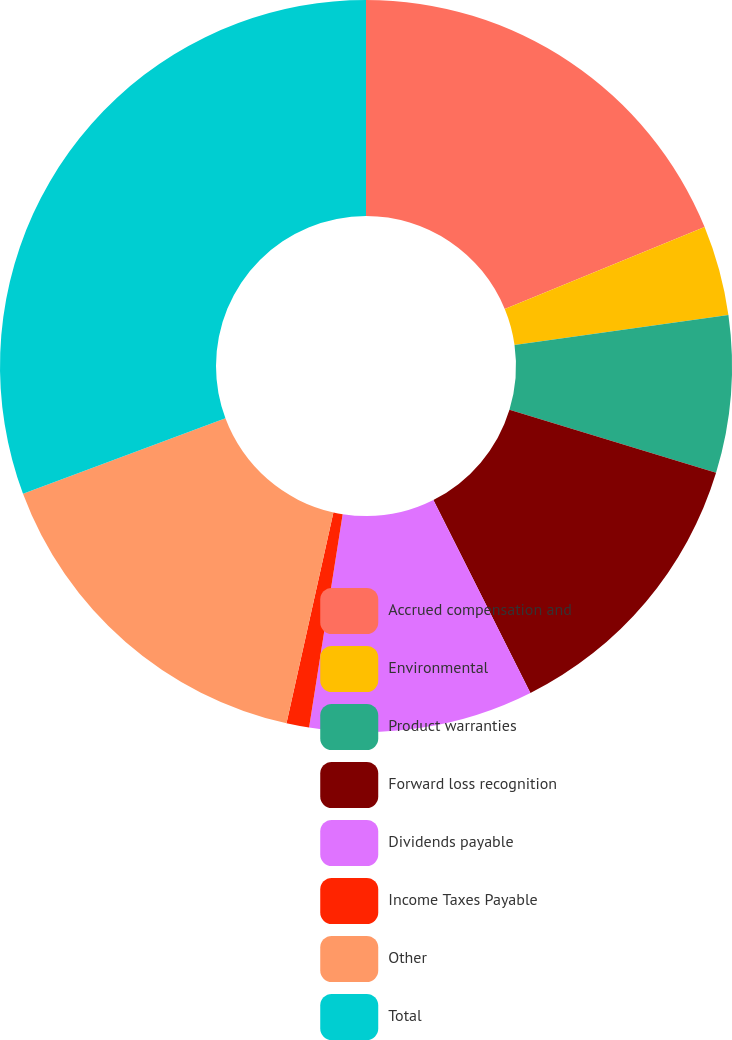<chart> <loc_0><loc_0><loc_500><loc_500><pie_chart><fcel>Accrued compensation and<fcel>Environmental<fcel>Product warranties<fcel>Forward loss recognition<fcel>Dividends payable<fcel>Income Taxes Payable<fcel>Other<fcel>Total<nl><fcel>18.8%<fcel>3.97%<fcel>6.94%<fcel>12.87%<fcel>9.9%<fcel>1.0%<fcel>15.84%<fcel>30.67%<nl></chart> 